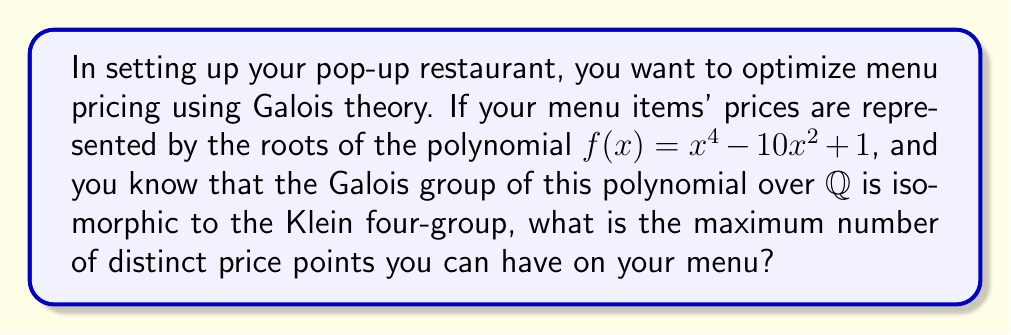Could you help me with this problem? Let's approach this step-by-step:

1) The polynomial $f(x) = x^4 - 10x^2 + 1$ is a biquadratic polynomial (a quartic polynomial with only even powers of x).

2) The Galois group being isomorphic to the Klein four-group tells us important information about the structure of the roots.

3) The Klein four-group has order 4 and is abelian. This means that all subgroups are normal, and the splitting field is obtained by a sequence of quadratic extensions.

4) For a biquadratic polynomial, this structure implies that the roots can be expressed as $\pm \sqrt{a}$ and $\pm \sqrt{b}$, where $a$ and $b$ are rational numbers.

5) We can factor the polynomial:
   $f(x) = (x^2 - a)(x^2 - b)$, where $a + b = 10$ and $ab = 1$

6) Solving this system of equations:
   $a + b = 10$
   $ab = 1$
   We get $a = 5 + 2\sqrt{6}$ and $b = 5 - 2\sqrt{6}$

7) Therefore, the roots of the polynomial are:
   $\pm \sqrt{5 + 2\sqrt{6}}$ and $\pm \sqrt{5 - 2\sqrt{6}}$

8) These four roots represent the possible price points. However, since we're dealing with prices, we only consider the positive roots.

9) Thus, there are two distinct positive roots: $\sqrt{5 + 2\sqrt{6}}$ and $\sqrt{5 - 2\sqrt{6}}$

Therefore, the maximum number of distinct price points on the menu is 2.
Answer: 2 